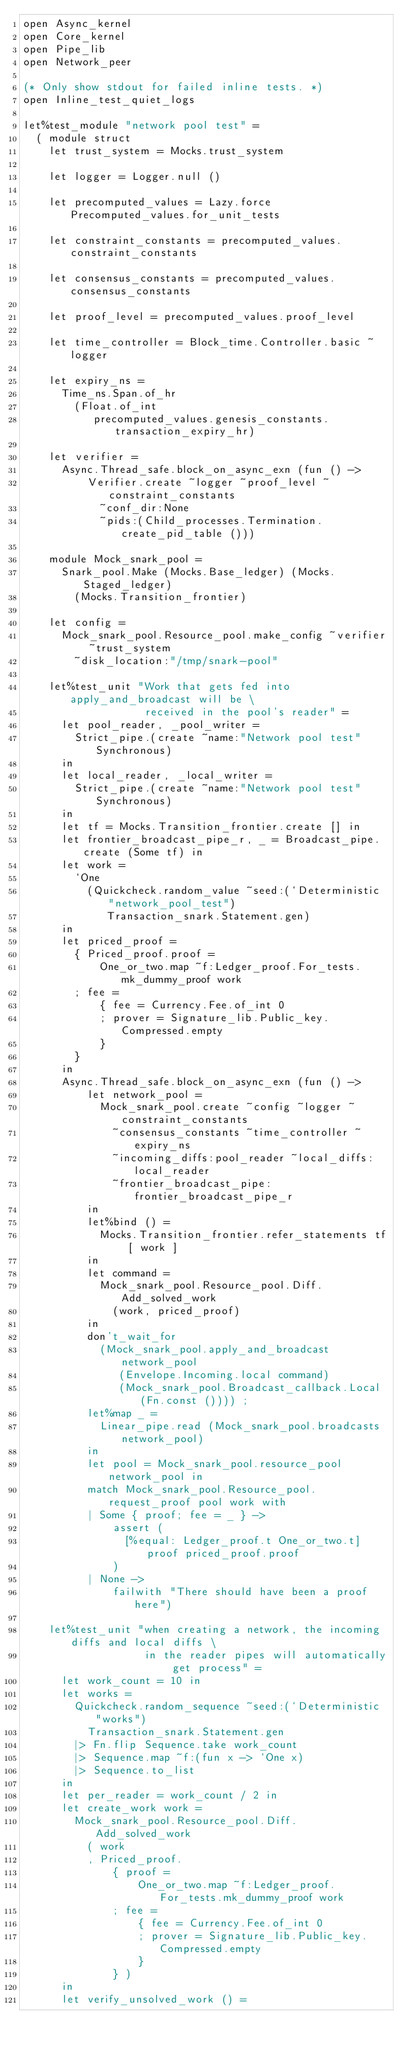Convert code to text. <code><loc_0><loc_0><loc_500><loc_500><_OCaml_>open Async_kernel
open Core_kernel
open Pipe_lib
open Network_peer

(* Only show stdout for failed inline tests. *)
open Inline_test_quiet_logs

let%test_module "network pool test" =
  ( module struct
    let trust_system = Mocks.trust_system

    let logger = Logger.null ()

    let precomputed_values = Lazy.force Precomputed_values.for_unit_tests

    let constraint_constants = precomputed_values.constraint_constants

    let consensus_constants = precomputed_values.consensus_constants

    let proof_level = precomputed_values.proof_level

    let time_controller = Block_time.Controller.basic ~logger

    let expiry_ns =
      Time_ns.Span.of_hr
        (Float.of_int
           precomputed_values.genesis_constants.transaction_expiry_hr)

    let verifier =
      Async.Thread_safe.block_on_async_exn (fun () ->
          Verifier.create ~logger ~proof_level ~constraint_constants
            ~conf_dir:None
            ~pids:(Child_processes.Termination.create_pid_table ()))

    module Mock_snark_pool =
      Snark_pool.Make (Mocks.Base_ledger) (Mocks.Staged_ledger)
        (Mocks.Transition_frontier)

    let config =
      Mock_snark_pool.Resource_pool.make_config ~verifier ~trust_system
        ~disk_location:"/tmp/snark-pool"

    let%test_unit "Work that gets fed into apply_and_broadcast will be \
                   received in the pool's reader" =
      let pool_reader, _pool_writer =
        Strict_pipe.(create ~name:"Network pool test" Synchronous)
      in
      let local_reader, _local_writer =
        Strict_pipe.(create ~name:"Network pool test" Synchronous)
      in
      let tf = Mocks.Transition_frontier.create [] in
      let frontier_broadcast_pipe_r, _ = Broadcast_pipe.create (Some tf) in
      let work =
        `One
          (Quickcheck.random_value ~seed:(`Deterministic "network_pool_test")
             Transaction_snark.Statement.gen)
      in
      let priced_proof =
        { Priced_proof.proof =
            One_or_two.map ~f:Ledger_proof.For_tests.mk_dummy_proof work
        ; fee =
            { fee = Currency.Fee.of_int 0
            ; prover = Signature_lib.Public_key.Compressed.empty
            }
        }
      in
      Async.Thread_safe.block_on_async_exn (fun () ->
          let network_pool =
            Mock_snark_pool.create ~config ~logger ~constraint_constants
              ~consensus_constants ~time_controller ~expiry_ns
              ~incoming_diffs:pool_reader ~local_diffs:local_reader
              ~frontier_broadcast_pipe:frontier_broadcast_pipe_r
          in
          let%bind () =
            Mocks.Transition_frontier.refer_statements tf [ work ]
          in
          let command =
            Mock_snark_pool.Resource_pool.Diff.Add_solved_work
              (work, priced_proof)
          in
          don't_wait_for
            (Mock_snark_pool.apply_and_broadcast network_pool
               (Envelope.Incoming.local command)
               (Mock_snark_pool.Broadcast_callback.Local (Fn.const ()))) ;
          let%map _ =
            Linear_pipe.read (Mock_snark_pool.broadcasts network_pool)
          in
          let pool = Mock_snark_pool.resource_pool network_pool in
          match Mock_snark_pool.Resource_pool.request_proof pool work with
          | Some { proof; fee = _ } ->
              assert (
                [%equal: Ledger_proof.t One_or_two.t] proof priced_proof.proof
              )
          | None ->
              failwith "There should have been a proof here")

    let%test_unit "when creating a network, the incoming diffs and local diffs \
                   in the reader pipes will automatically get process" =
      let work_count = 10 in
      let works =
        Quickcheck.random_sequence ~seed:(`Deterministic "works")
          Transaction_snark.Statement.gen
        |> Fn.flip Sequence.take work_count
        |> Sequence.map ~f:(fun x -> `One x)
        |> Sequence.to_list
      in
      let per_reader = work_count / 2 in
      let create_work work =
        Mock_snark_pool.Resource_pool.Diff.Add_solved_work
          ( work
          , Priced_proof.
              { proof =
                  One_or_two.map ~f:Ledger_proof.For_tests.mk_dummy_proof work
              ; fee =
                  { fee = Currency.Fee.of_int 0
                  ; prover = Signature_lib.Public_key.Compressed.empty
                  }
              } )
      in
      let verify_unsolved_work () =</code> 